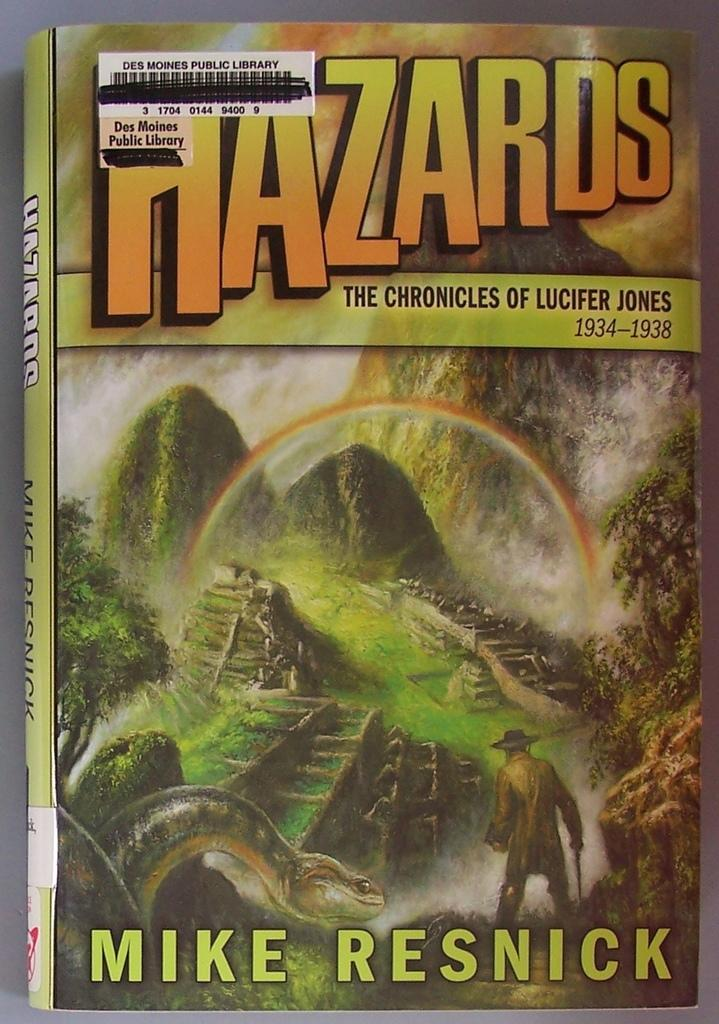<image>
Provide a brief description of the given image. a book that is called Hazards and is yellowish 